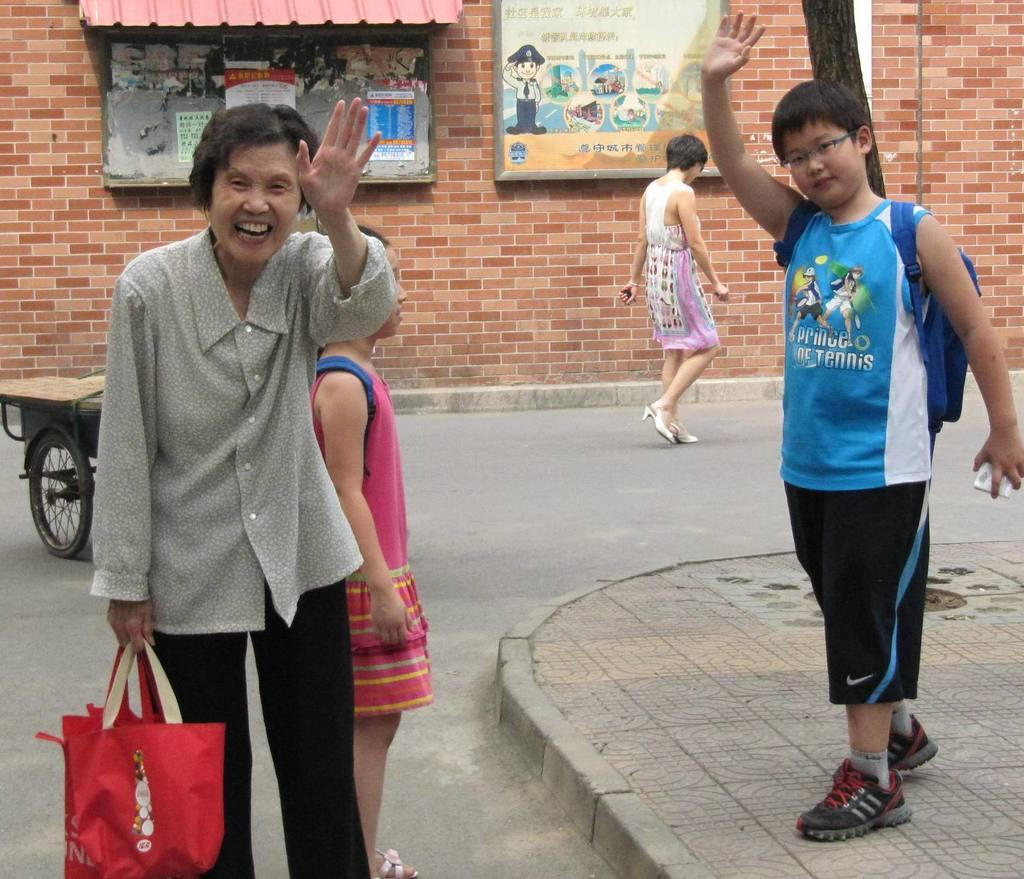What are the two people in the front doing in the image? The two people in the front are standing and waving their hands. Are there any other people visible in the image? Yes, there are two other people standing behind them. What is the color and material of the background wall in the image? The background wall is brick in color. What type of calculator can be seen in the pocket of one of the people in the image? There is no calculator or pocket visible in the image. 